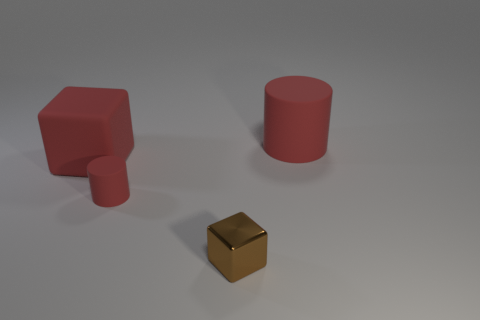How do the shadows cast by the objects inform us about the light source? The shadows in the image are soft and extend to the lower right of the objects, suggesting that the light source is positioned to the upper left, somewhat elevated in relation to the objects. The shadows have soft edges, which indicates that the light source is not extremely close and that it is diffused, casting a gentle light across the scene. 